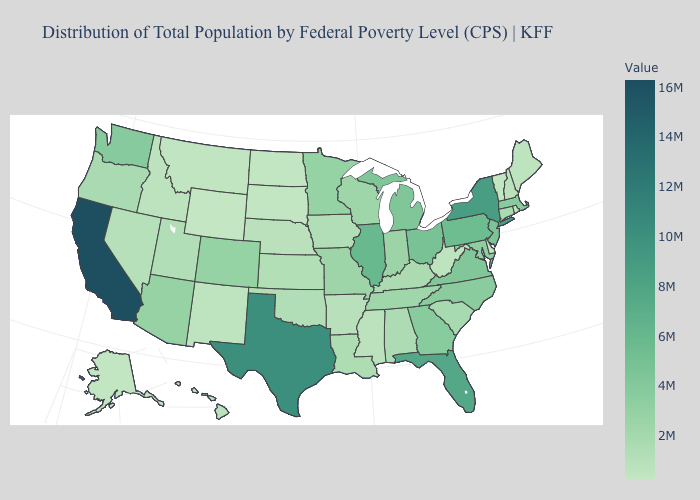Does Wyoming have the lowest value in the USA?
Quick response, please. Yes. Which states hav the highest value in the South?
Be succinct. Texas. Which states have the highest value in the USA?
Be succinct. California. 